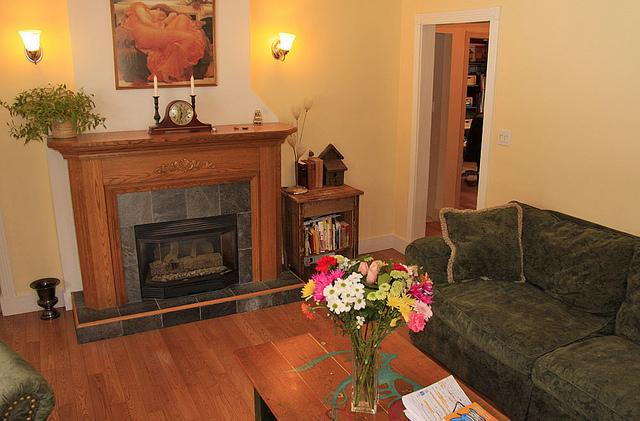How many portraits are hung above the fireplace mantle?

Choices:
A) three
B) four
C) one
D) two one 